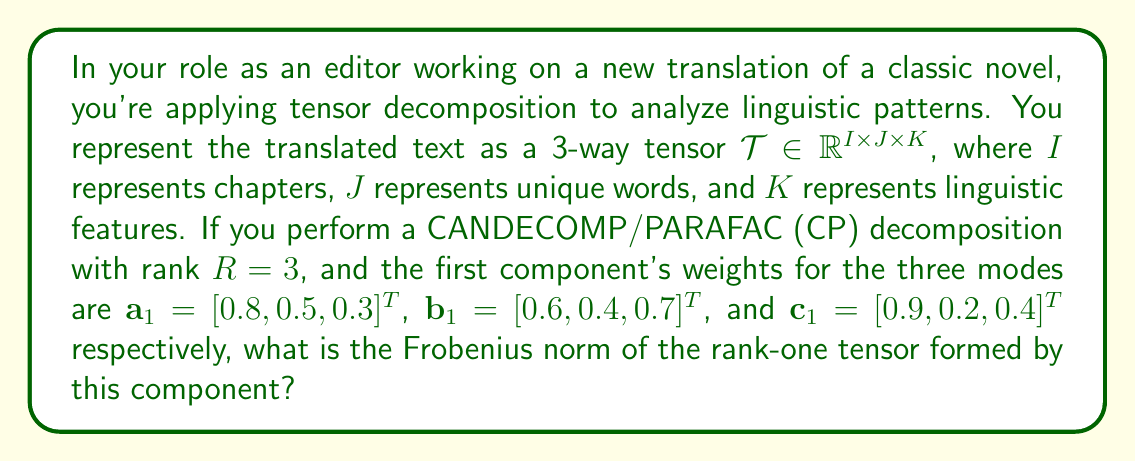Give your solution to this math problem. Let's approach this step-by-step:

1) The CP decomposition of a 3-way tensor $\mathcal{T}$ can be written as:

   $$\mathcal{T} \approx \sum_{r=1}^R \mathbf{a}_r \circ \mathbf{b}_r \circ \mathbf{c}_r$$

   where $\circ$ denotes the outer product.

2) We're focusing on the first component $(r=1)$, which forms a rank-one tensor:

   $$\mathcal{T}_1 = \mathbf{a}_1 \circ \mathbf{b}_1 \circ \mathbf{c}_1$$

3) The Frobenius norm of a tensor is the square root of the sum of the squares of all its elements. For a rank-one tensor formed by the outer product of three vectors, this is equal to the product of the Euclidean norms of these vectors:

   $$\|\mathcal{T}_1\|_F = \|\mathbf{a}_1\|_2 \cdot \|\mathbf{b}_1\|_2 \cdot \|\mathbf{c}_1\|_2$$

4) Let's calculate the Euclidean norm of each vector:

   $\|\mathbf{a}_1\|_2 = \sqrt{0.8^2 + 0.5^2 + 0.3^2} = \sqrt{0.64 + 0.25 + 0.09} = \sqrt{0.98} = 0.9899$

   $\|\mathbf{b}_1\|_2 = \sqrt{0.6^2 + 0.4^2 + 0.7^2} = \sqrt{0.36 + 0.16 + 0.49} = \sqrt{1.01} = 1.0050$

   $\|\mathbf{c}_1\|_2 = \sqrt{0.9^2 + 0.2^2 + 0.4^2} = \sqrt{0.81 + 0.04 + 0.16} = \sqrt{1.01} = 1.0050$

5) Now, we multiply these norms:

   $\|\mathcal{T}_1\|_F = 0.9899 \cdot 1.0050 \cdot 1.0050 = 0.9998$

Therefore, the Frobenius norm of the rank-one tensor formed by the first component is approximately 0.9998.
Answer: 0.9998 